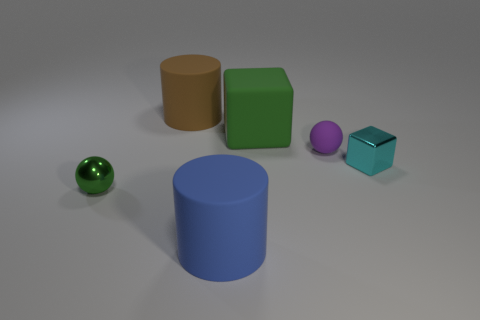Add 2 tiny gray matte things. How many objects exist? 8 Subtract all blocks. How many objects are left? 4 Subtract all metal objects. Subtract all big brown cylinders. How many objects are left? 3 Add 4 small green objects. How many small green objects are left? 5 Add 5 cyan metallic blocks. How many cyan metallic blocks exist? 6 Subtract 1 blue cylinders. How many objects are left? 5 